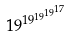<formula> <loc_0><loc_0><loc_500><loc_500>1 9 ^ { 1 9 ^ { 1 9 ^ { 1 9 ^ { 1 7 } } } }</formula> 